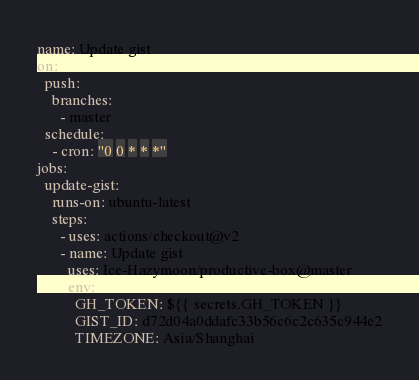Convert code to text. <code><loc_0><loc_0><loc_500><loc_500><_YAML_>name: Update gist
on:
  push:
    branches:
      - master
  schedule:
    - cron: "0 0 * * *"
jobs:
  update-gist:
    runs-on: ubuntu-latest
    steps:
      - uses: actions/checkout@v2
      - name: Update gist
        uses: Ice-Hazymoon/productive-box@master
        env:
          GH_TOKEN: ${{ secrets.GH_TOKEN }}
          GIST_ID: d72d04a0ddafc33b56c6c2c635c944e2
          TIMEZONE: Asia/Shanghai
</code> 